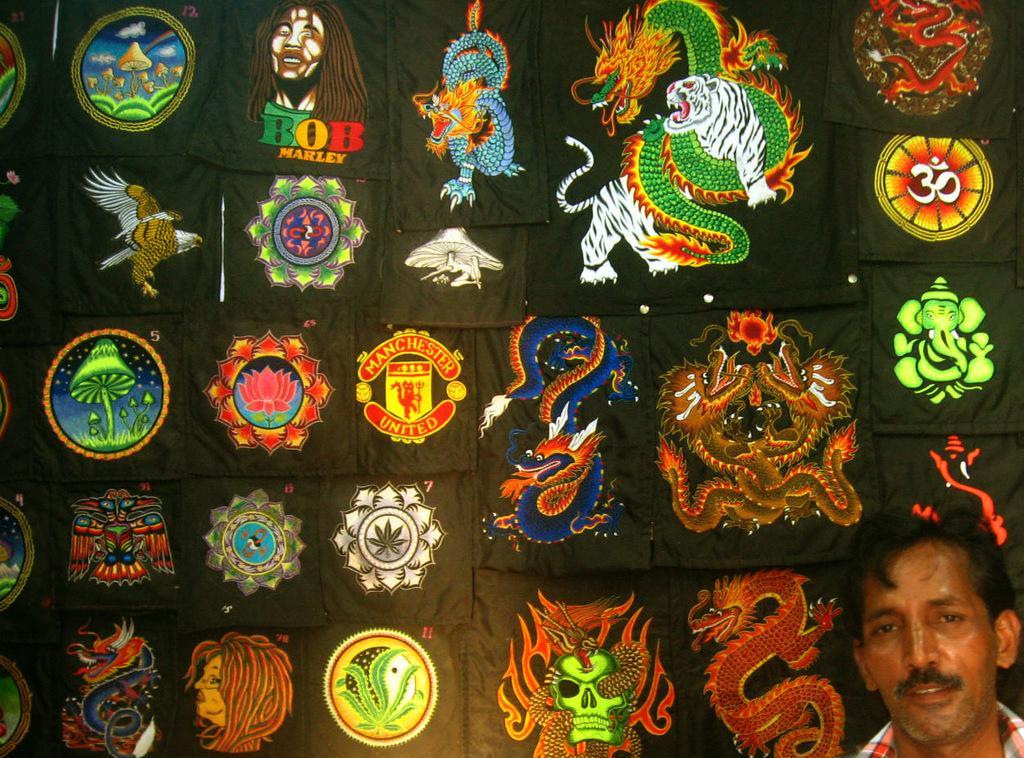Describe this image in one or two sentences. In this picture we can see a person in the bottom right. There are a few images of animals, people, flowers, plants, logos, symbols, gods and other things on a black surface. 